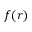Convert formula to latex. <formula><loc_0><loc_0><loc_500><loc_500>f ( r )</formula> 